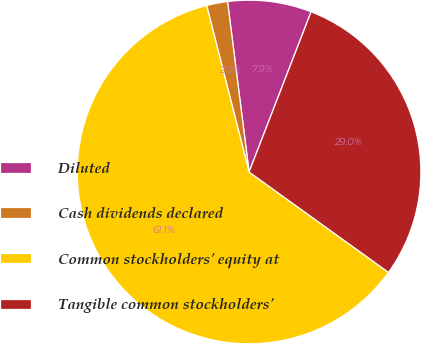Convert chart. <chart><loc_0><loc_0><loc_500><loc_500><pie_chart><fcel>Diluted<fcel>Cash dividends declared<fcel>Common stockholders' equity at<fcel>Tangible common stockholders'<nl><fcel>7.88%<fcel>1.97%<fcel>61.1%<fcel>29.05%<nl></chart> 